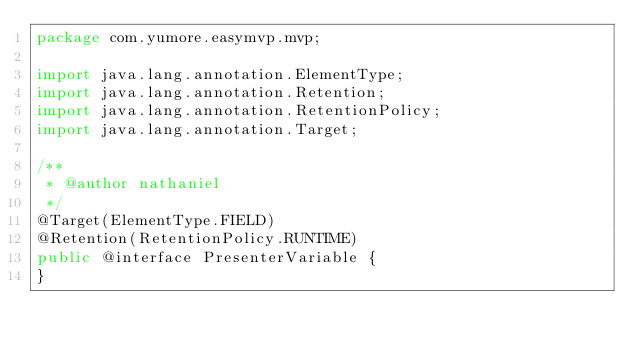<code> <loc_0><loc_0><loc_500><loc_500><_Java_>package com.yumore.easymvp.mvp;

import java.lang.annotation.ElementType;
import java.lang.annotation.Retention;
import java.lang.annotation.RetentionPolicy;
import java.lang.annotation.Target;

/**
 * @author nathaniel
 */
@Target(ElementType.FIELD)
@Retention(RetentionPolicy.RUNTIME)
public @interface PresenterVariable {
}
</code> 